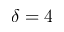<formula> <loc_0><loc_0><loc_500><loc_500>\delta = 4</formula> 